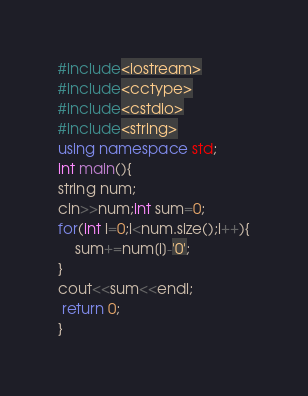Convert code to text. <code><loc_0><loc_0><loc_500><loc_500><_C++_>#include<iostream>
#include<cctype>
#include<cstdio>
#include<string>
using namespace std;
int main(){
string num;
cin>>num;int sum=0;
for(int i=0;i<num.size();i++){
	sum+=num[i]-'0';
}
cout<<sum<<endl;
 return 0;
}</code> 